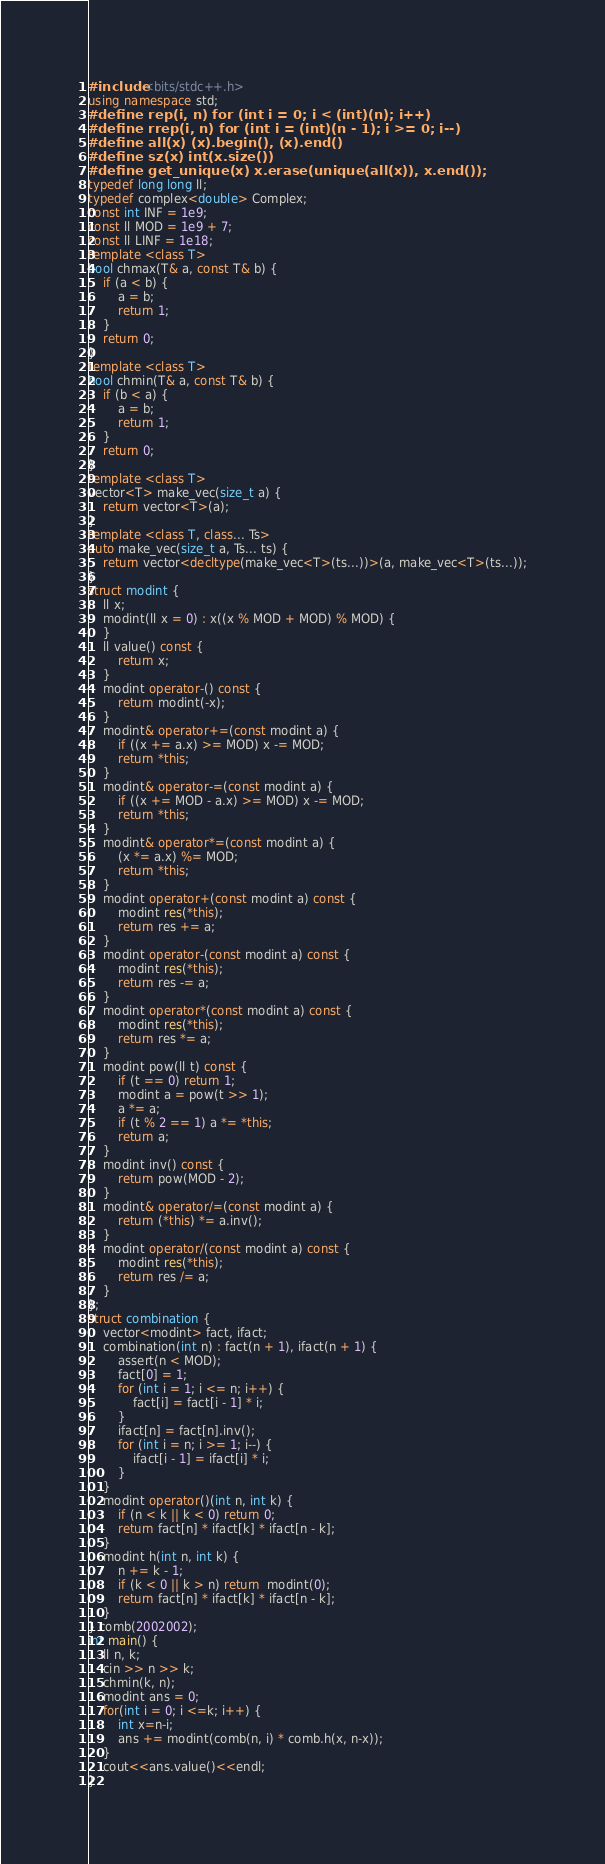<code> <loc_0><loc_0><loc_500><loc_500><_C++_>#include <bits/stdc++.h>
using namespace std;
#define rep(i, n) for (int i = 0; i < (int)(n); i++)
#define rrep(i, n) for (int i = (int)(n - 1); i >= 0; i--)
#define all(x) (x).begin(), (x).end()
#define sz(x) int(x.size())
#define get_unique(x) x.erase(unique(all(x)), x.end());
typedef long long ll;
typedef complex<double> Complex;
const int INF = 1e9;
const ll MOD = 1e9 + 7;
const ll LINF = 1e18;
template <class T>
bool chmax(T& a, const T& b) {
    if (a < b) {
        a = b;
        return 1;
    }
    return 0;
}
template <class T>
bool chmin(T& a, const T& b) {
    if (b < a) {
        a = b;
        return 1;
    }
    return 0;
}
template <class T>
vector<T> make_vec(size_t a) {
    return vector<T>(a);
}
template <class T, class... Ts>
auto make_vec(size_t a, Ts... ts) {
    return vector<decltype(make_vec<T>(ts...))>(a, make_vec<T>(ts...));
}
struct modint {
    ll x;
    modint(ll x = 0) : x((x % MOD + MOD) % MOD) {
    }
    ll value() const {
        return x;
    }
    modint operator-() const {
        return modint(-x);
    }
    modint& operator+=(const modint a) {
        if ((x += a.x) >= MOD) x -= MOD;
        return *this;
    }
    modint& operator-=(const modint a) {
        if ((x += MOD - a.x) >= MOD) x -= MOD;
        return *this;
    }
    modint& operator*=(const modint a) {
        (x *= a.x) %= MOD;
        return *this;
    }
    modint operator+(const modint a) const {
        modint res(*this);
        return res += a;
    }
    modint operator-(const modint a) const {
        modint res(*this);
        return res -= a;
    }
    modint operator*(const modint a) const {
        modint res(*this);
        return res *= a;
    }
    modint pow(ll t) const {
        if (t == 0) return 1;
        modint a = pow(t >> 1);
        a *= a;
        if (t % 2 == 1) a *= *this;
        return a;
    }
    modint inv() const {
        return pow(MOD - 2);
    }
    modint& operator/=(const modint a) {
        return (*this) *= a.inv();
    }
    modint operator/(const modint a) const {
        modint res(*this);
        return res /= a;
    }
};
struct combination {
    vector<modint> fact, ifact;
    combination(int n) : fact(n + 1), ifact(n + 1) {
        assert(n < MOD);
        fact[0] = 1;
        for (int i = 1; i <= n; i++) {
            fact[i] = fact[i - 1] * i;
        }
        ifact[n] = fact[n].inv();
        for (int i = n; i >= 1; i--) {
            ifact[i - 1] = ifact[i] * i;
        }
    }
    modint operator()(int n, int k) {
        if (n < k || k < 0) return 0;
        return fact[n] * ifact[k] * ifact[n - k];
    }
    modint h(int n, int k) {
        n += k - 1;
        if (k < 0 || k > n) return  modint(0);
        return fact[n] * ifact[k] * ifact[n - k];
    }
} comb(2002002);
int main() {
    ll n, k;
    cin >> n >> k;
    chmin(k, n);
    modint ans = 0;
    for(int i = 0; i <=k; i++) {
        int x=n-i;
        ans += modint(comb(n, i) * comb.h(x, n-x));
    }
    cout<<ans.value()<<endl;
}
</code> 